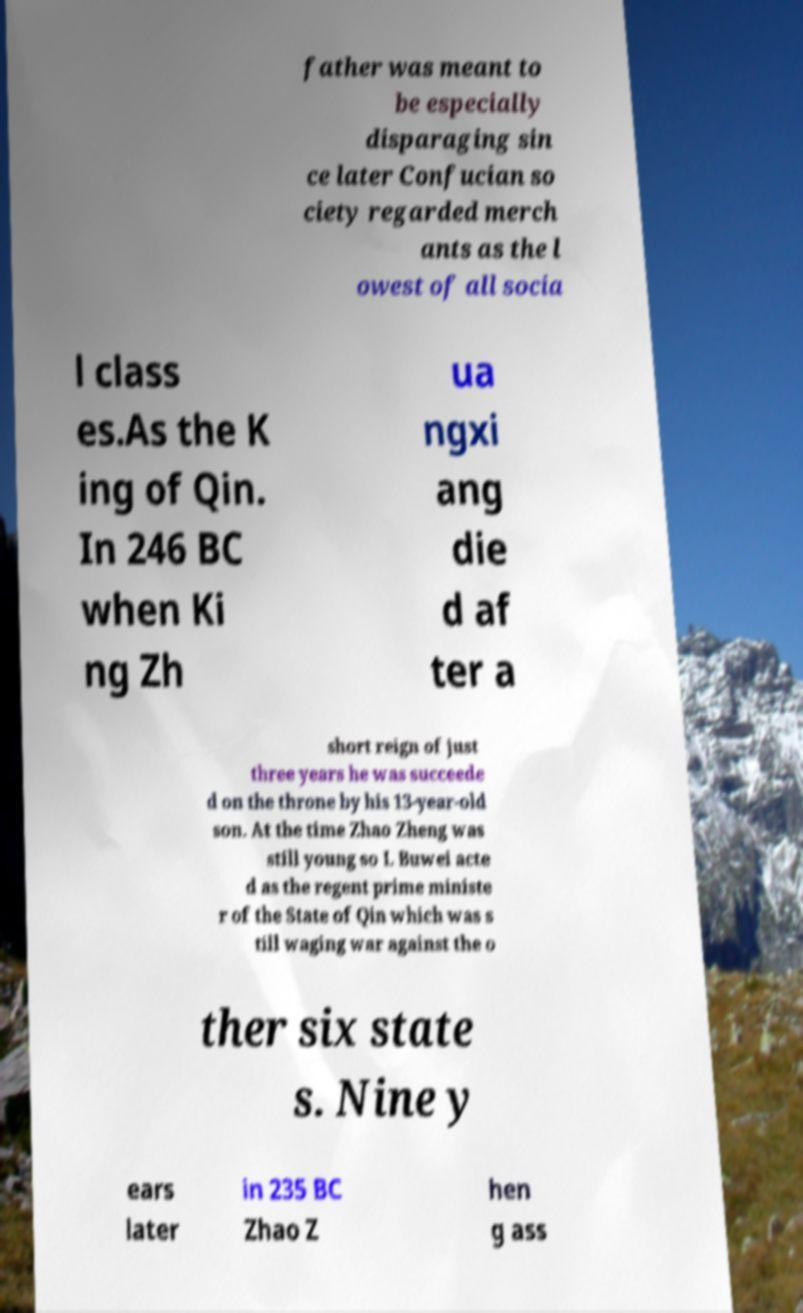What messages or text are displayed in this image? I need them in a readable, typed format. father was meant to be especially disparaging sin ce later Confucian so ciety regarded merch ants as the l owest of all socia l class es.As the K ing of Qin. In 246 BC when Ki ng Zh ua ngxi ang die d af ter a short reign of just three years he was succeede d on the throne by his 13-year-old son. At the time Zhao Zheng was still young so L Buwei acte d as the regent prime ministe r of the State of Qin which was s till waging war against the o ther six state s. Nine y ears later in 235 BC Zhao Z hen g ass 